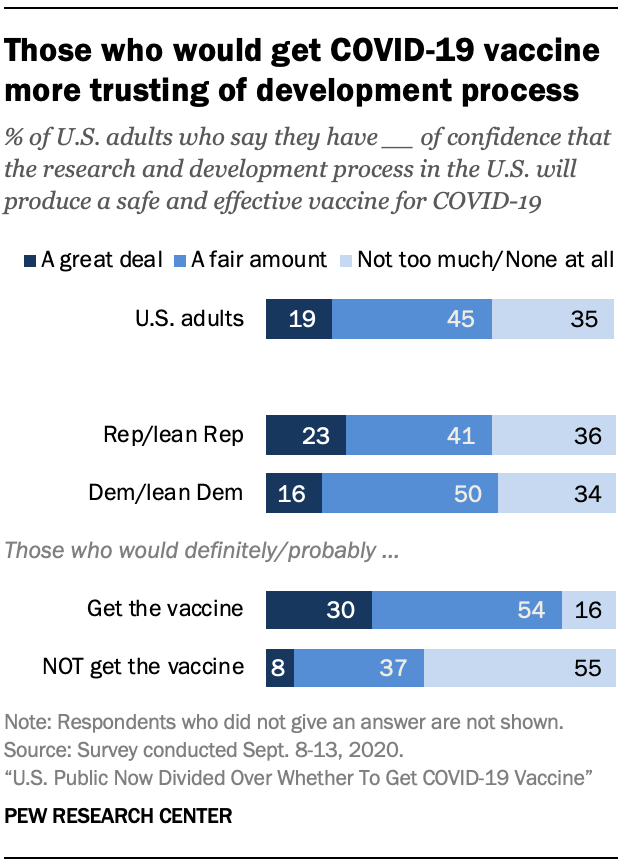Indicate a few pertinent items in this graphic. The ratio between getting a vaccine and not getting a vaccine in the "Not Get the vaccine" category is 0.371527778... According to a survey conducted among US adults, the majority believe that a "great deal" is the appropriate response to the question "What is the value in US adults think 'A great deal' for the question ? 19..". 